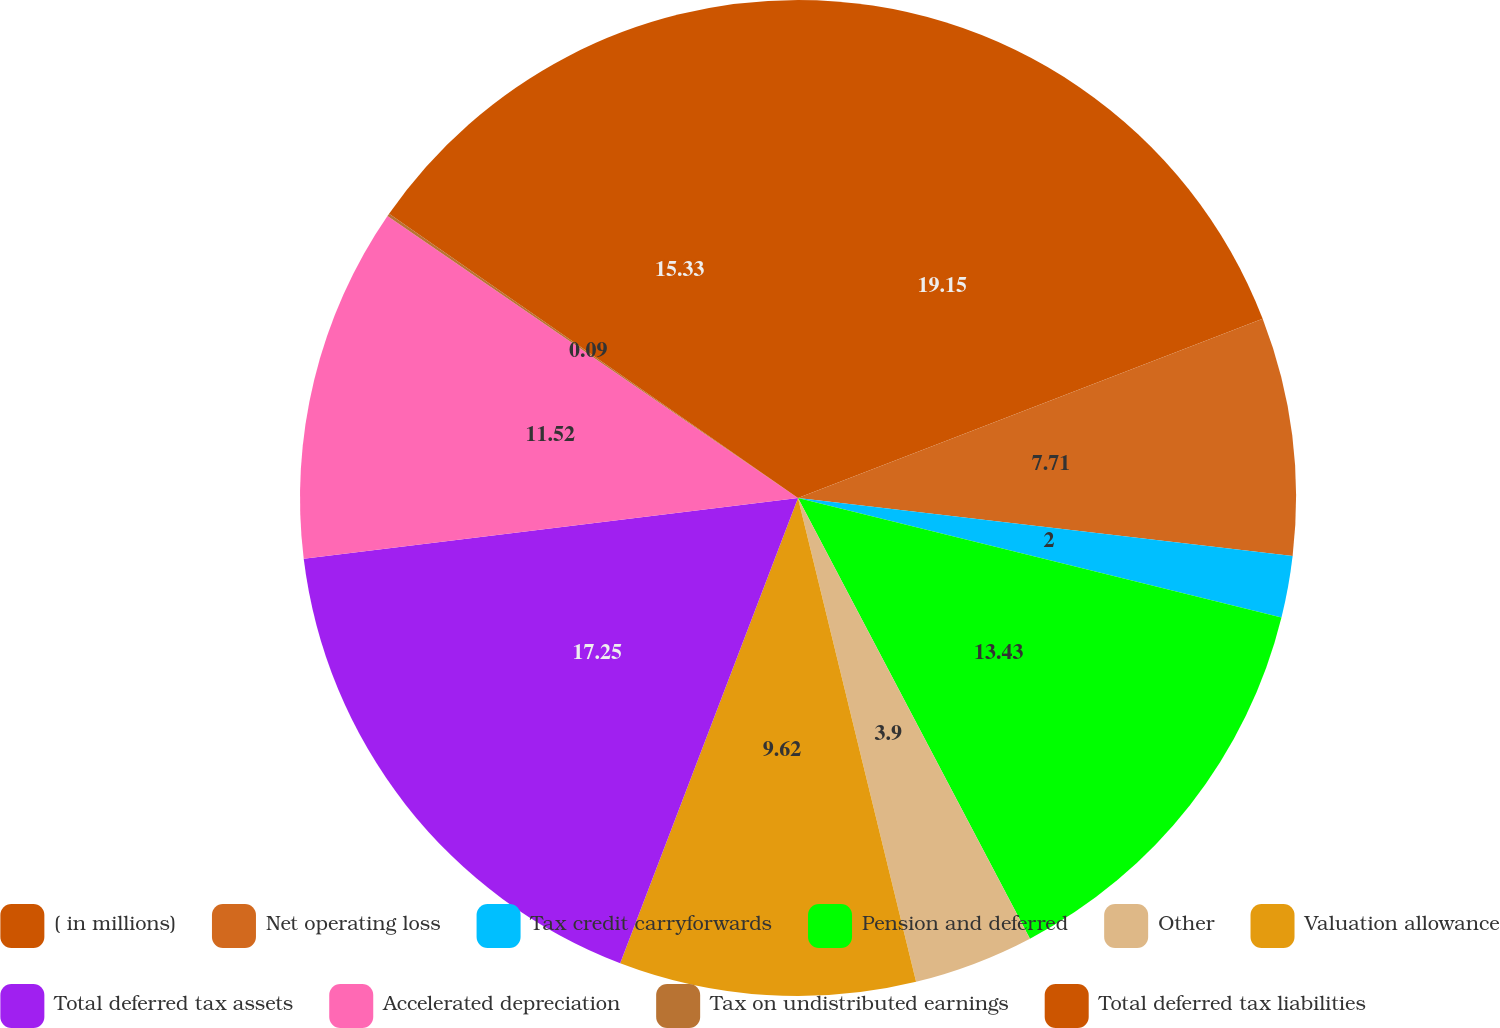Convert chart to OTSL. <chart><loc_0><loc_0><loc_500><loc_500><pie_chart><fcel>( in millions)<fcel>Net operating loss<fcel>Tax credit carryforwards<fcel>Pension and deferred<fcel>Other<fcel>Valuation allowance<fcel>Total deferred tax assets<fcel>Accelerated depreciation<fcel>Tax on undistributed earnings<fcel>Total deferred tax liabilities<nl><fcel>19.14%<fcel>7.71%<fcel>2.0%<fcel>13.43%<fcel>3.9%<fcel>9.62%<fcel>17.24%<fcel>11.52%<fcel>0.09%<fcel>15.33%<nl></chart> 